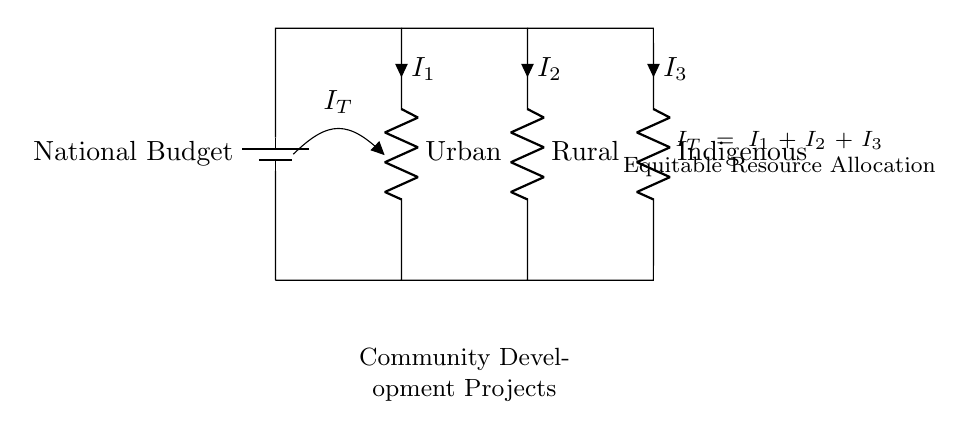What is the total current flowing in this network? The total current, denoted as IT, represents the sum of the currents in each branch. The equation provided in the diagram shows that IT equals the sum of I1, I2, and I3. Thus, IT can be determined by analyzing the connections between the components.
Answer: IT Which branch represents the Urban allocation? The Urban allocation is indicated by the resistor labeled "Urban" in this circuit diagram. Its connection begins at the higher potential side and connects back to the battery's other terminal, showing where the allocated resources flow.
Answer: Urban How many branches are present in the current divider? By observing the circuit, there are three distinct branches through which current can flow: Urban, Rural, and Indigenous. Each branch is connected in parallel to the same voltage source, indicating separate paths for current distribution.
Answer: Three What equation represents current conservation in this circuit? The equation of current conservation in this circuit is represented as IT equals I1 plus I2 plus I3. This is a fundamental principle in electrical circuits, ensuring that the total current entering a junction equals the total current leaving it.
Answer: IT = I1 + I2 + I3 What does the presence of parallel resistors indicate in this context? The presence of parallel resistors signifies that resources are being allocated simultaneously among various sectors such as Urban, Rural, and Indigenous. Each branch can receive or utilize current (resources) independently, suggesting equitable distribution.
Answer: Equitable distribution 